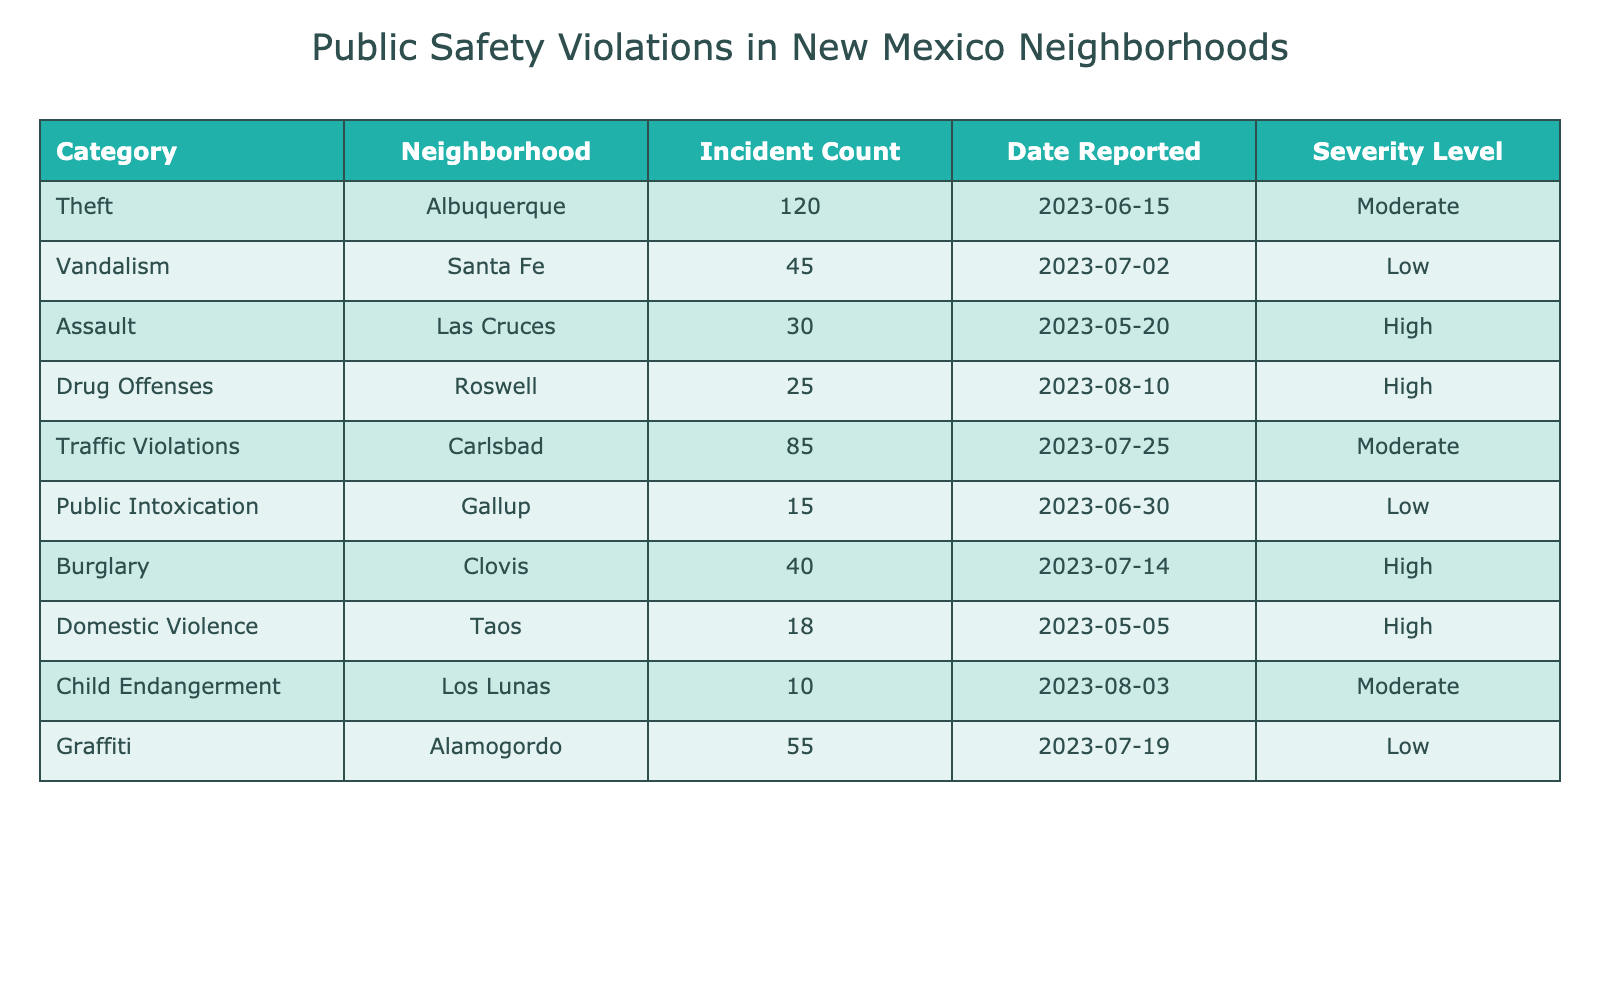What category has the highest incident count? By reviewing the 'Incident Count' column in the table, we can determine that the highest number of incidents is reported under the category 'Theft' in Albuquerque, with a total of 120 incidents.
Answer: Theft How many drug offenses were reported in Roswell? Looking at the table under the 'Drug Offenses' category specifically for Roswell, the incident count is listed as 25.
Answer: 25 Is there any neighborhood with reported incidents of child endangerment? The table indicates that 'Child Endangerment' is listed in Los Lunas, with an incident count of 10. Therefore, yes, there are reported incidents in that neighborhood.
Answer: Yes What is the total number of assault incidents reported across all neighborhoods? To find the total, we refer only to the category 'Assault,' which has an incident count of 30 in Las Cruces. Since it is the only instance of assault recorded in the table, the total is 30.
Answer: 30 Which neighborhood has the lowest incident count, and what category does it belong to? By examining the incident counts, 'Public Intoxication' in Gallup has the lowest count at 15 incidents. Therefore, the neighborhood with the lowest incident count is Gallup, categorized under Public Intoxication.
Answer: Gallup; Public Intoxication What percentage of reported incidents in the table are classified as high severity? First, we identify the number of high severity incidents. There are 4 categories with high severity ('Assault,' 'Drug Offenses,' 'Burglary,' and 'Domestic Violence'), totaling 30 + 25 + 40 + 18 = 113 incidents. The total incident count in the table is 120 + 45 + 30 + 25 + 85 + 15 + 40 + 18 + 10 + 55 = 423. The percentage is calculated as (113 / 423) * 100 ≈ 26.7%.
Answer: Approximately 26.7% Are there any incidents of vandalism reported in Albuquerque? By checking the 'Vandalism' category in the table, we see that it is not recorded in Albuquerque; it is reported in Santa Fe only. Therefore, the answer is no.
Answer: No What is the average number of incidents reported per neighborhood listed in the table? To find the average, we sum the incident counts: 120 + 45 + 30 + 25 + 85 + 15 + 40 + 18 + 10 + 55 = 425. There are 10 neighborhoods in total, so the average is 425 / 10 = 42.5.
Answer: 42.5 Which has more incidents, traffic violations or vandalism? From the table, traffic violations in Carlsbad total 85 incidents, while vandalism in Santa Fe is at 45 incidents. Therefore, traffic violations are higher.
Answer: Traffic violations What is the severity level of the incident reported in the neighborhood of Clovis? In the 'Burglary' category for Clovis, the severity level is categorized as 'High' according to the table.
Answer: High 